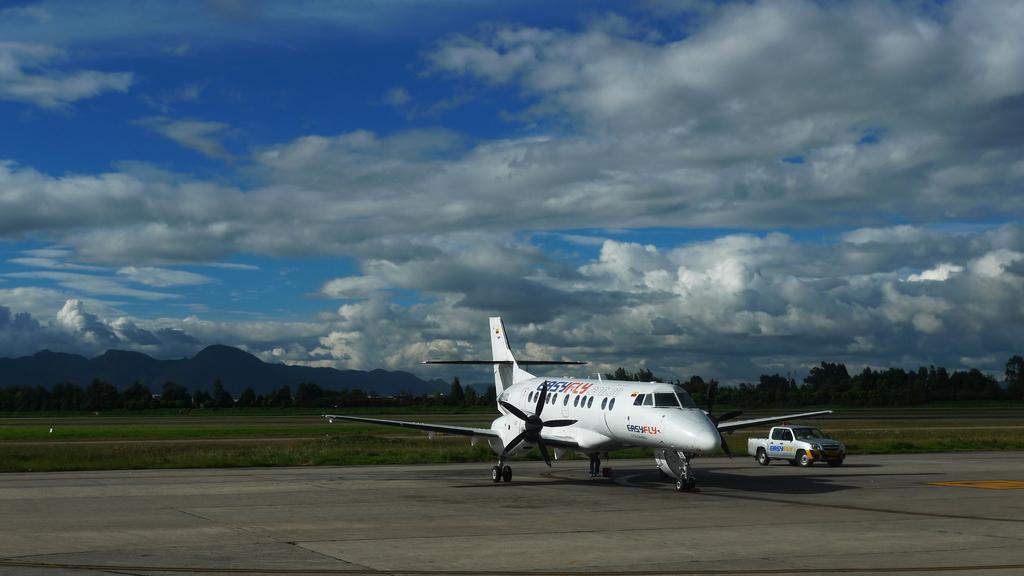Describe this image in one or two sentences. In this image there is airplane and a jeep, in the background there is a field, trees, mountain and a cloudy sky. 